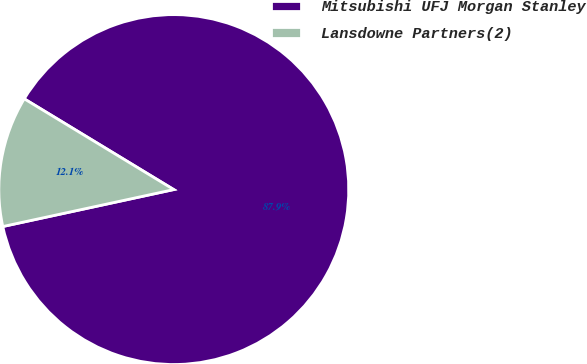Convert chart. <chart><loc_0><loc_0><loc_500><loc_500><pie_chart><fcel>Mitsubishi UFJ Morgan Stanley<fcel>Lansdowne Partners(2)<nl><fcel>87.93%<fcel>12.07%<nl></chart> 